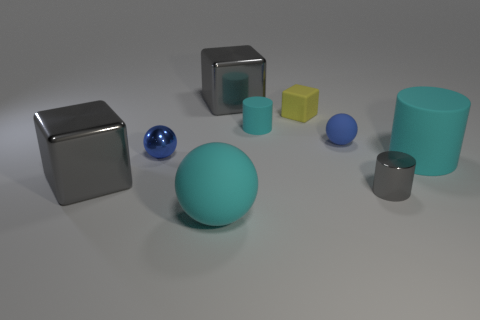How many blue balls must be subtracted to get 1 blue balls? 1 Add 1 big cyan metallic blocks. How many objects exist? 10 Subtract all tiny rubber cubes. How many cubes are left? 2 Subtract all cylinders. How many objects are left? 6 Subtract 1 balls. How many balls are left? 2 Add 9 tiny matte blocks. How many tiny matte blocks exist? 10 Subtract all cyan cylinders. How many cylinders are left? 1 Subtract 1 cyan cylinders. How many objects are left? 8 Subtract all cyan cylinders. Subtract all blue spheres. How many cylinders are left? 1 Subtract all blue cylinders. How many gray spheres are left? 0 